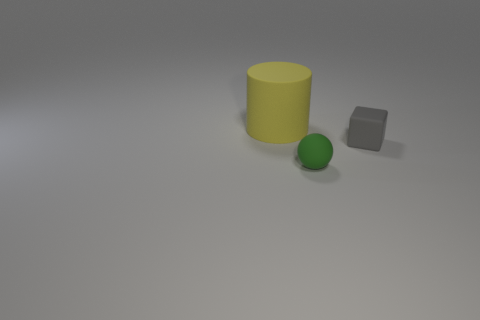Add 2 small blocks. How many objects exist? 5 Subtract all spheres. How many objects are left? 2 Add 2 gray things. How many gray things are left? 3 Add 2 big yellow matte objects. How many big yellow matte objects exist? 3 Subtract 0 gray cylinders. How many objects are left? 3 Subtract all gray matte objects. Subtract all big matte objects. How many objects are left? 1 